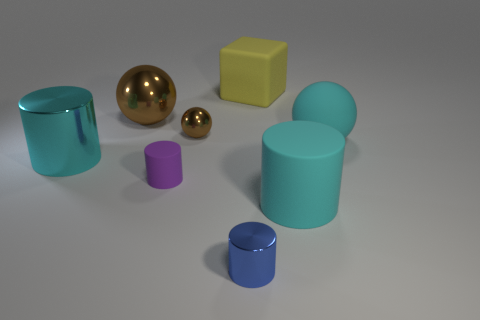There is a purple thing; does it have the same shape as the brown object that is right of the small purple matte cylinder?
Your answer should be very brief. No. How many objects are either balls that are to the right of the purple object or small cylinders?
Provide a short and direct response. 4. Are the small blue object and the large cylinder on the left side of the tiny metallic cylinder made of the same material?
Keep it short and to the point. Yes. There is a rubber object that is to the left of the metallic cylinder in front of the cyan metallic cylinder; what is its shape?
Provide a short and direct response. Cylinder. Is the color of the small matte object the same as the thing on the right side of the big cyan rubber cylinder?
Give a very brief answer. No. Is there any other thing that has the same material as the tiny brown thing?
Keep it short and to the point. Yes. There is a small blue metal object; what shape is it?
Your answer should be compact. Cylinder. What size is the brown sphere that is to the left of the rubber thing that is on the left side of the yellow object?
Ensure brevity in your answer.  Large. Are there the same number of yellow cubes in front of the big cyan rubber sphere and tiny blue shiny things left of the small brown object?
Give a very brief answer. Yes. The small thing that is both to the right of the tiny purple cylinder and in front of the tiny brown metallic thing is made of what material?
Make the answer very short. Metal. 